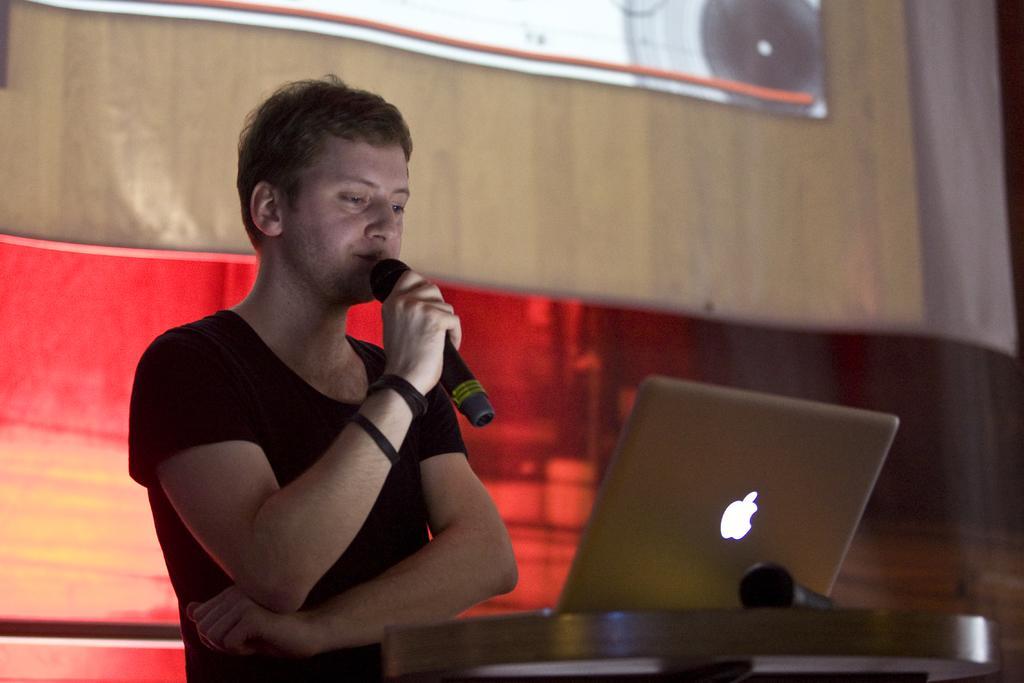Could you give a brief overview of what you see in this image? In the picture a person catching a microphone and standing in front of a table on the table there is a laptop there is a wall behind the person. 